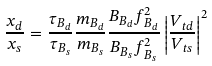Convert formula to latex. <formula><loc_0><loc_0><loc_500><loc_500>\frac { x _ { d } } { x _ { s } } = \frac { \tau _ { B _ { d } } } { \tau _ { B _ { s } } } \frac { m _ { B _ { d } } } { m _ { B _ { s } } } \frac { B _ { B _ { d } } f ^ { 2 } _ { B _ { d } } } { B _ { B _ { s } } f ^ { 2 } _ { B _ { s } } } \left | \frac { V _ { t d } } { V _ { t s } } \right | ^ { 2 }</formula> 